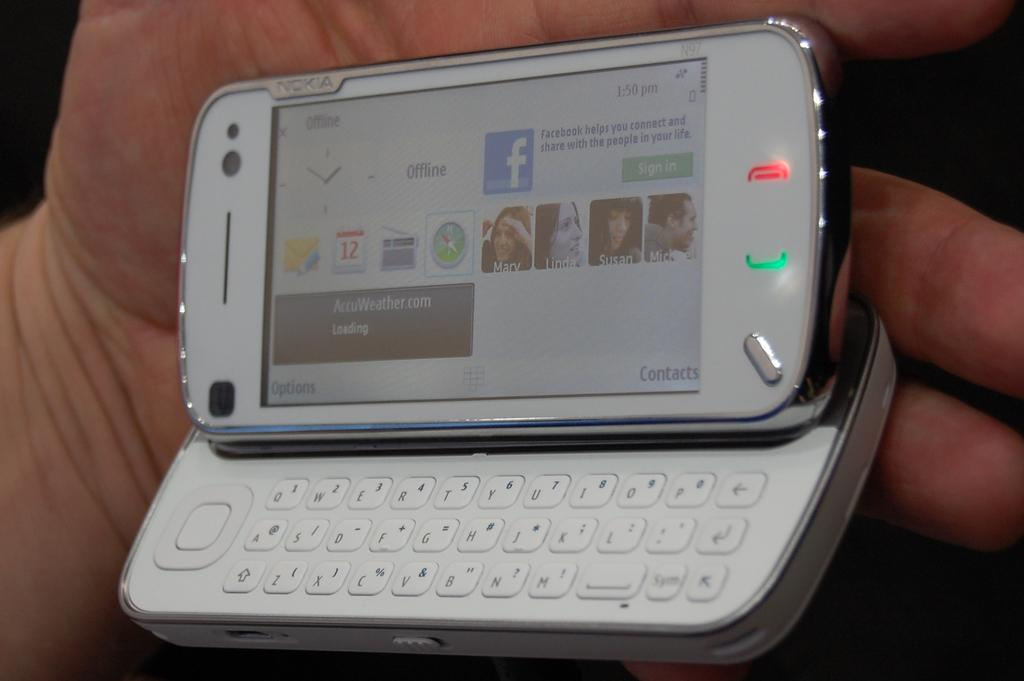<image>
Provide a brief description of the given image. a phone that has the word offline on it 